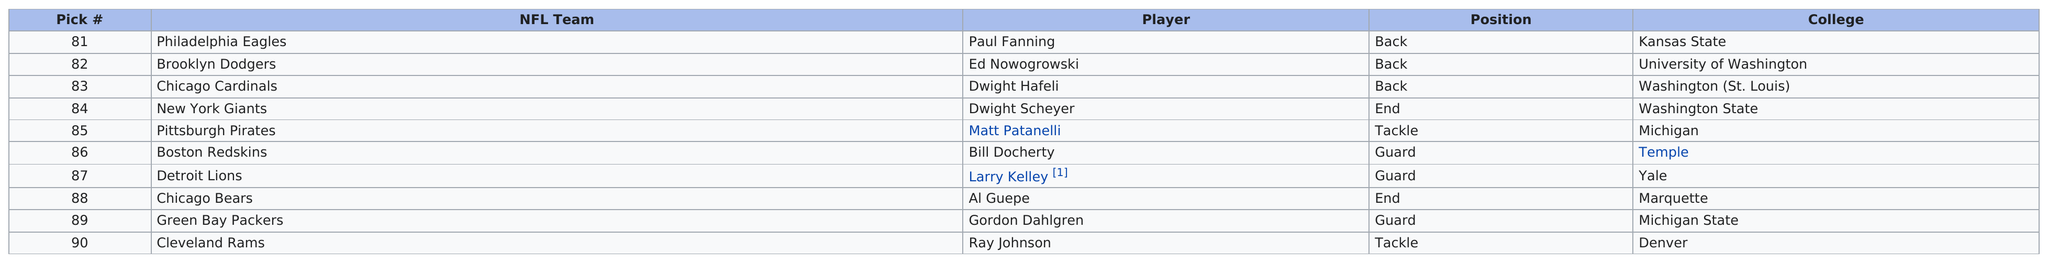List a handful of essential elements in this visual. Ray Johnson was the last pick of the ninth round of the 1937 NFL draft. The Chicago Bears drafted an end in round nine, just like the New York Giants did, making them the only two teams to do so during that time period. In the ninth round, a total of three players who played as guards were selected. In the ninth round of the 1937 NFL Draft, a total of three guards were selected. Out of the players drafted in the ninth round, three of them were guards. 